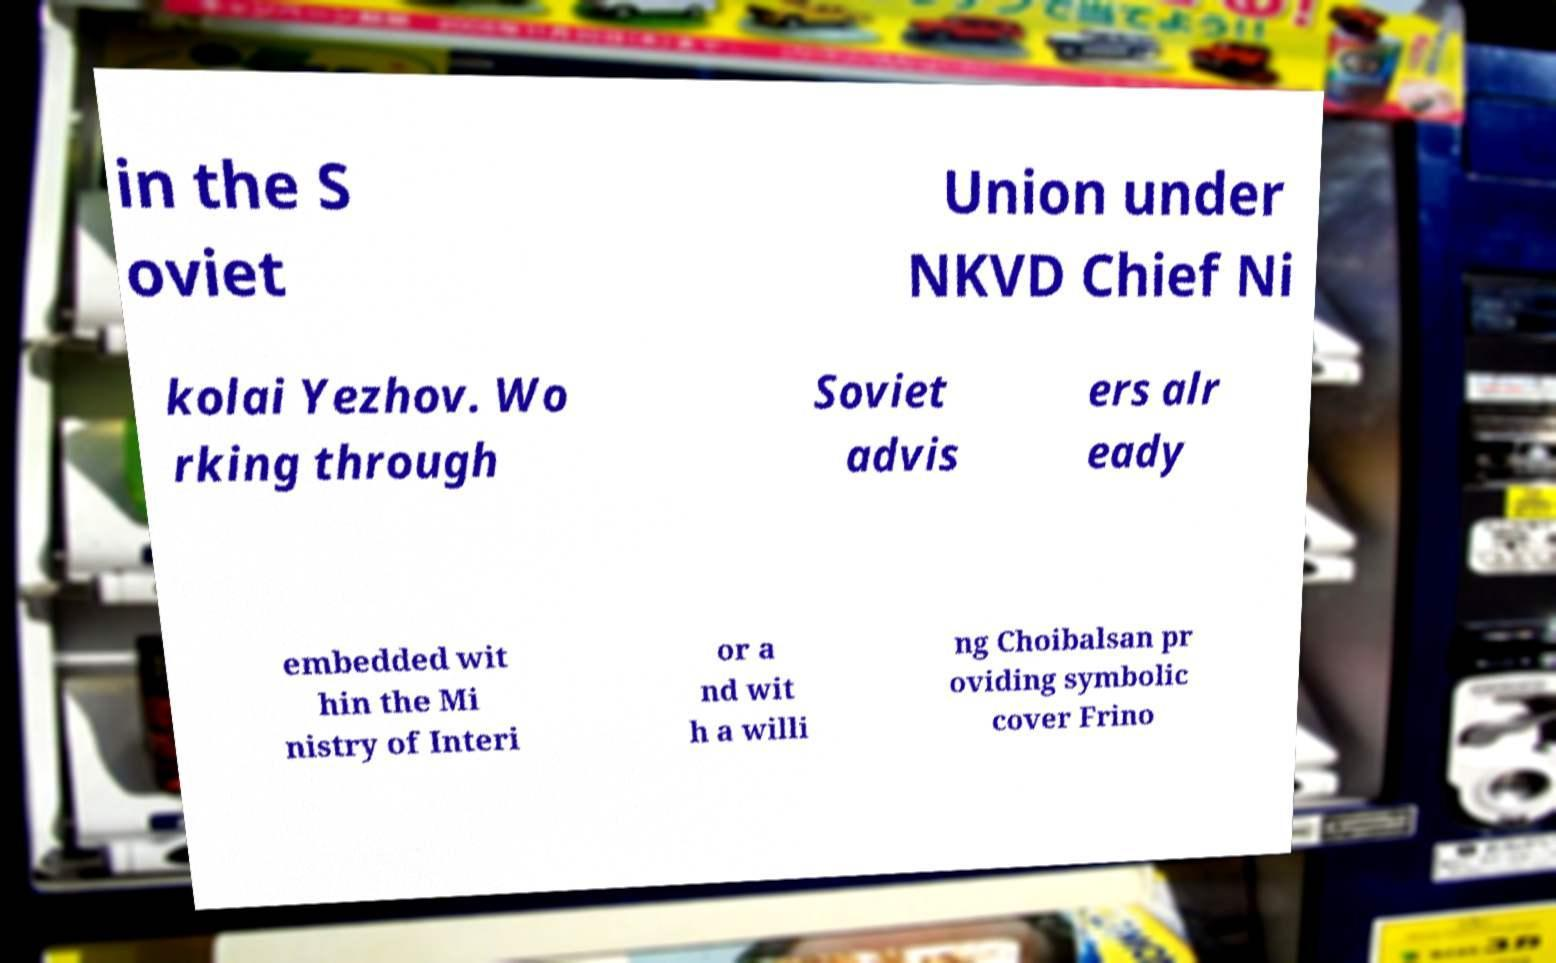I need the written content from this picture converted into text. Can you do that? in the S oviet Union under NKVD Chief Ni kolai Yezhov. Wo rking through Soviet advis ers alr eady embedded wit hin the Mi nistry of Interi or a nd wit h a willi ng Choibalsan pr oviding symbolic cover Frino 